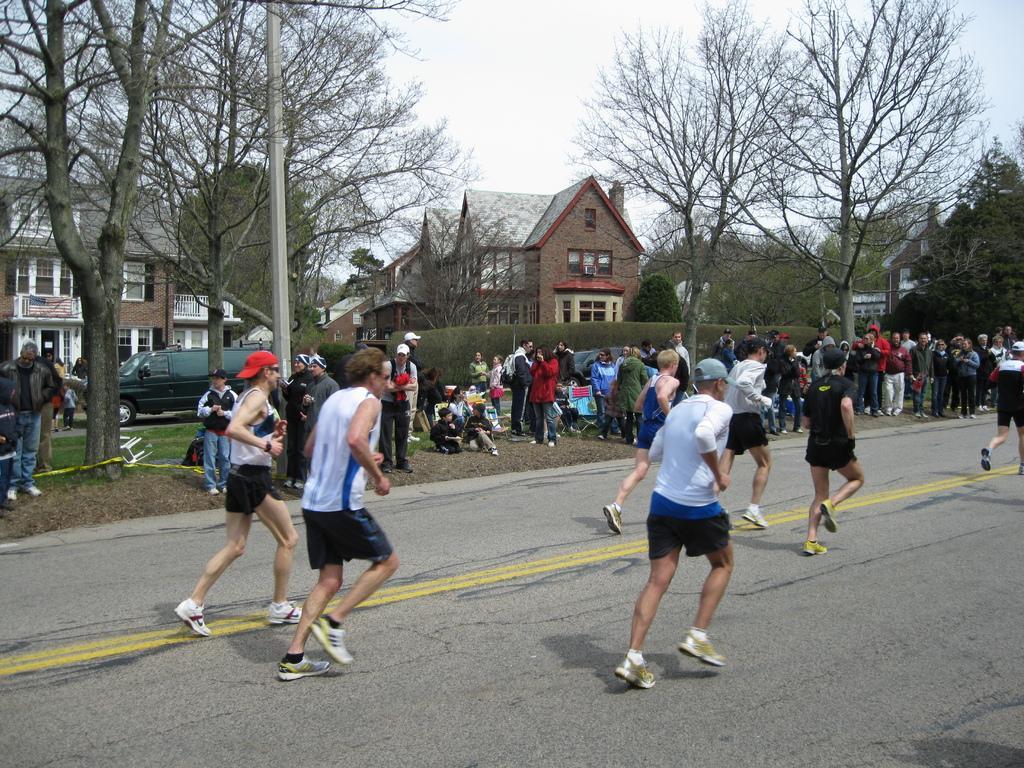Describe this image in one or two sentences. There is a group of persons running on a road at the bottom of this image and there are some persons standing in the background. There are some trees and buildings present in the middle of this image, and there is a vehicle on the left side of this image. There is a sky at the top of this image. 